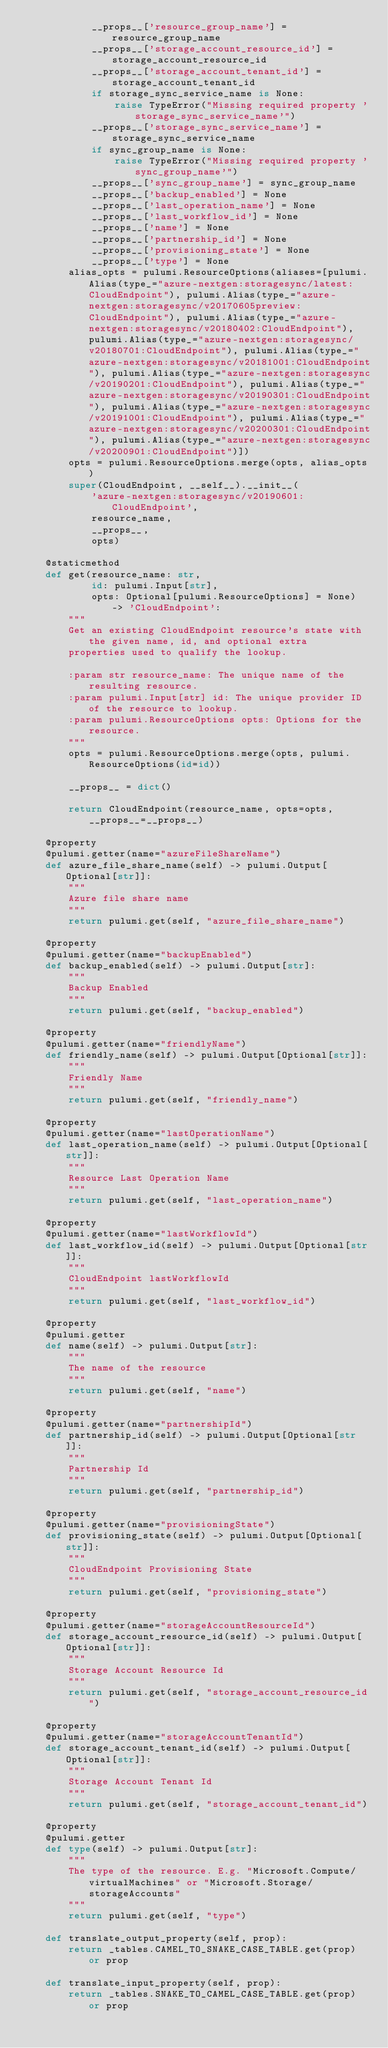<code> <loc_0><loc_0><loc_500><loc_500><_Python_>            __props__['resource_group_name'] = resource_group_name
            __props__['storage_account_resource_id'] = storage_account_resource_id
            __props__['storage_account_tenant_id'] = storage_account_tenant_id
            if storage_sync_service_name is None:
                raise TypeError("Missing required property 'storage_sync_service_name'")
            __props__['storage_sync_service_name'] = storage_sync_service_name
            if sync_group_name is None:
                raise TypeError("Missing required property 'sync_group_name'")
            __props__['sync_group_name'] = sync_group_name
            __props__['backup_enabled'] = None
            __props__['last_operation_name'] = None
            __props__['last_workflow_id'] = None
            __props__['name'] = None
            __props__['partnership_id'] = None
            __props__['provisioning_state'] = None
            __props__['type'] = None
        alias_opts = pulumi.ResourceOptions(aliases=[pulumi.Alias(type_="azure-nextgen:storagesync/latest:CloudEndpoint"), pulumi.Alias(type_="azure-nextgen:storagesync/v20170605preview:CloudEndpoint"), pulumi.Alias(type_="azure-nextgen:storagesync/v20180402:CloudEndpoint"), pulumi.Alias(type_="azure-nextgen:storagesync/v20180701:CloudEndpoint"), pulumi.Alias(type_="azure-nextgen:storagesync/v20181001:CloudEndpoint"), pulumi.Alias(type_="azure-nextgen:storagesync/v20190201:CloudEndpoint"), pulumi.Alias(type_="azure-nextgen:storagesync/v20190301:CloudEndpoint"), pulumi.Alias(type_="azure-nextgen:storagesync/v20191001:CloudEndpoint"), pulumi.Alias(type_="azure-nextgen:storagesync/v20200301:CloudEndpoint"), pulumi.Alias(type_="azure-nextgen:storagesync/v20200901:CloudEndpoint")])
        opts = pulumi.ResourceOptions.merge(opts, alias_opts)
        super(CloudEndpoint, __self__).__init__(
            'azure-nextgen:storagesync/v20190601:CloudEndpoint',
            resource_name,
            __props__,
            opts)

    @staticmethod
    def get(resource_name: str,
            id: pulumi.Input[str],
            opts: Optional[pulumi.ResourceOptions] = None) -> 'CloudEndpoint':
        """
        Get an existing CloudEndpoint resource's state with the given name, id, and optional extra
        properties used to qualify the lookup.

        :param str resource_name: The unique name of the resulting resource.
        :param pulumi.Input[str] id: The unique provider ID of the resource to lookup.
        :param pulumi.ResourceOptions opts: Options for the resource.
        """
        opts = pulumi.ResourceOptions.merge(opts, pulumi.ResourceOptions(id=id))

        __props__ = dict()

        return CloudEndpoint(resource_name, opts=opts, __props__=__props__)

    @property
    @pulumi.getter(name="azureFileShareName")
    def azure_file_share_name(self) -> pulumi.Output[Optional[str]]:
        """
        Azure file share name
        """
        return pulumi.get(self, "azure_file_share_name")

    @property
    @pulumi.getter(name="backupEnabled")
    def backup_enabled(self) -> pulumi.Output[str]:
        """
        Backup Enabled
        """
        return pulumi.get(self, "backup_enabled")

    @property
    @pulumi.getter(name="friendlyName")
    def friendly_name(self) -> pulumi.Output[Optional[str]]:
        """
        Friendly Name
        """
        return pulumi.get(self, "friendly_name")

    @property
    @pulumi.getter(name="lastOperationName")
    def last_operation_name(self) -> pulumi.Output[Optional[str]]:
        """
        Resource Last Operation Name
        """
        return pulumi.get(self, "last_operation_name")

    @property
    @pulumi.getter(name="lastWorkflowId")
    def last_workflow_id(self) -> pulumi.Output[Optional[str]]:
        """
        CloudEndpoint lastWorkflowId
        """
        return pulumi.get(self, "last_workflow_id")

    @property
    @pulumi.getter
    def name(self) -> pulumi.Output[str]:
        """
        The name of the resource
        """
        return pulumi.get(self, "name")

    @property
    @pulumi.getter(name="partnershipId")
    def partnership_id(self) -> pulumi.Output[Optional[str]]:
        """
        Partnership Id
        """
        return pulumi.get(self, "partnership_id")

    @property
    @pulumi.getter(name="provisioningState")
    def provisioning_state(self) -> pulumi.Output[Optional[str]]:
        """
        CloudEndpoint Provisioning State
        """
        return pulumi.get(self, "provisioning_state")

    @property
    @pulumi.getter(name="storageAccountResourceId")
    def storage_account_resource_id(self) -> pulumi.Output[Optional[str]]:
        """
        Storage Account Resource Id
        """
        return pulumi.get(self, "storage_account_resource_id")

    @property
    @pulumi.getter(name="storageAccountTenantId")
    def storage_account_tenant_id(self) -> pulumi.Output[Optional[str]]:
        """
        Storage Account Tenant Id
        """
        return pulumi.get(self, "storage_account_tenant_id")

    @property
    @pulumi.getter
    def type(self) -> pulumi.Output[str]:
        """
        The type of the resource. E.g. "Microsoft.Compute/virtualMachines" or "Microsoft.Storage/storageAccounts"
        """
        return pulumi.get(self, "type")

    def translate_output_property(self, prop):
        return _tables.CAMEL_TO_SNAKE_CASE_TABLE.get(prop) or prop

    def translate_input_property(self, prop):
        return _tables.SNAKE_TO_CAMEL_CASE_TABLE.get(prop) or prop

</code> 